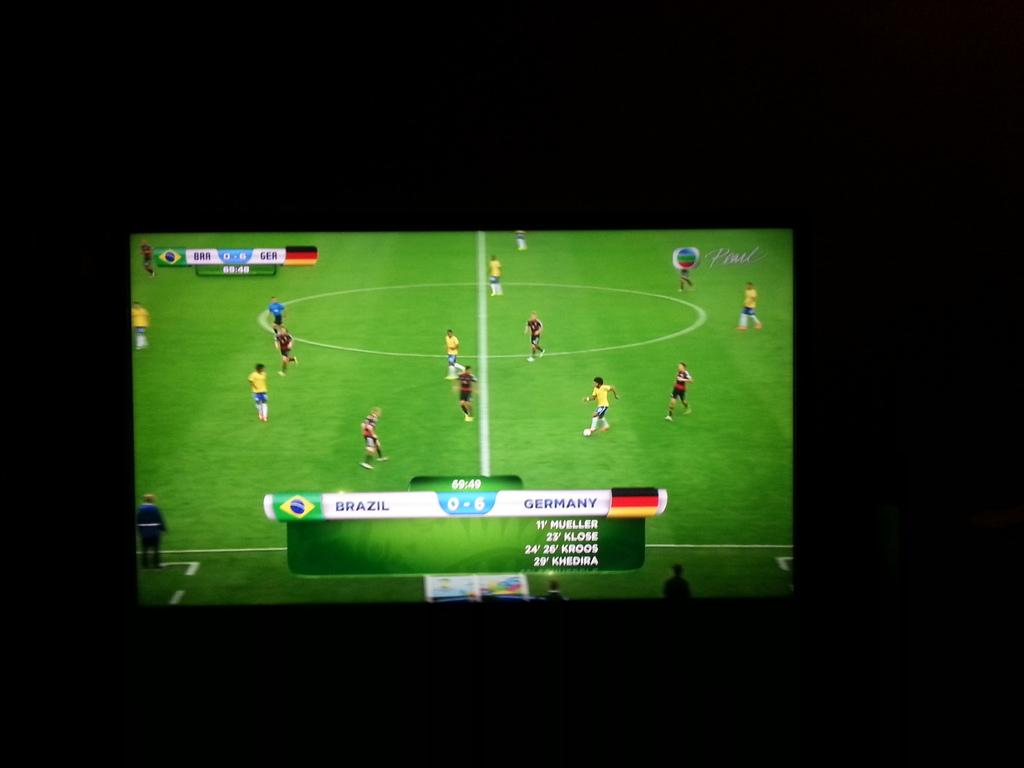<image>
Describe the image concisely. a Germany game is on the television screen 